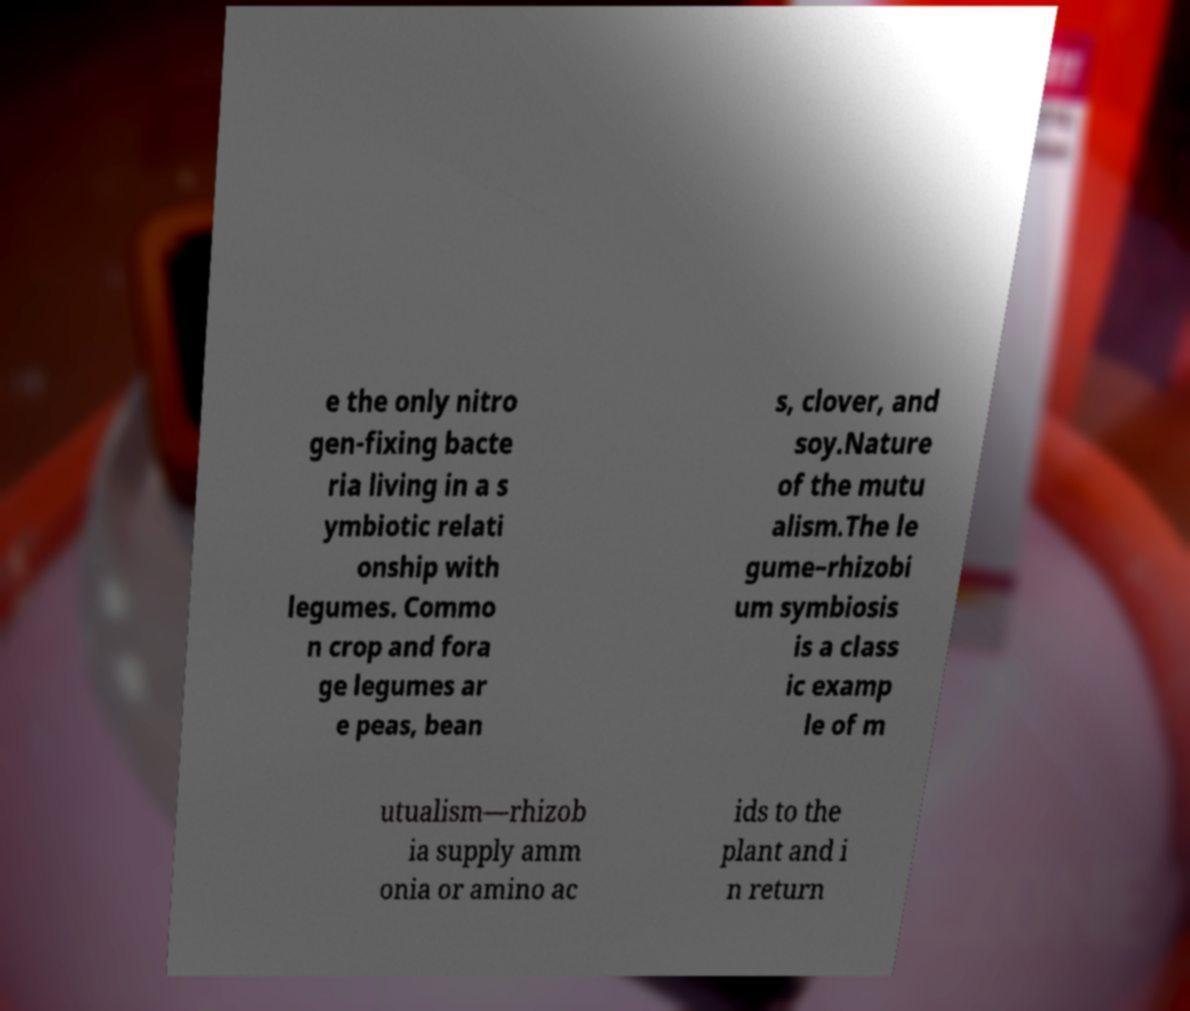Could you extract and type out the text from this image? e the only nitro gen-fixing bacte ria living in a s ymbiotic relati onship with legumes. Commo n crop and fora ge legumes ar e peas, bean s, clover, and soy.Nature of the mutu alism.The le gume–rhizobi um symbiosis is a class ic examp le of m utualism—rhizob ia supply amm onia or amino ac ids to the plant and i n return 